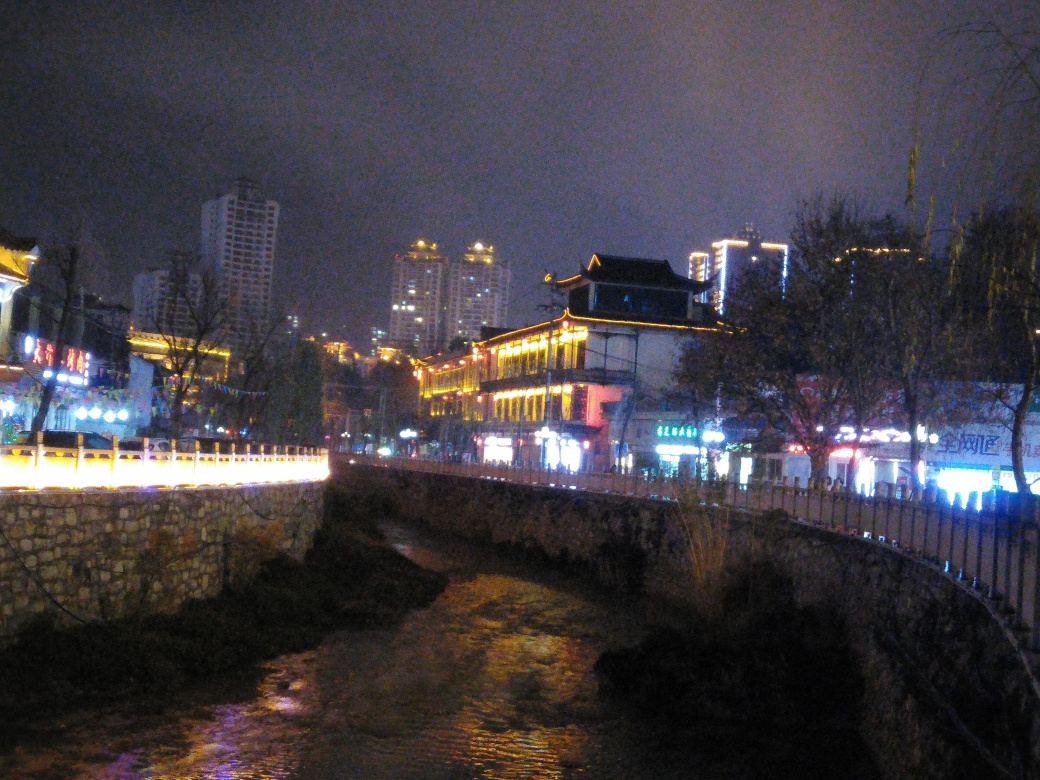What can you tell me about the atmosphere of the location in the image? The image exudes an ambience that is both vibrant and serene. The evening setting is brought to life with a mix of natural and artificial lighting, casting a soft glow on the scene. The illuminated ancient building provides a nostalgic contrast with the modern cityscape in the background, offering a glimpse into a culture that celebrates its historical legacy amidst urban progression. The peaceful flow of the adjacent river adds a tranquil element, likely making this a contemplative and attractive space for visitors. 